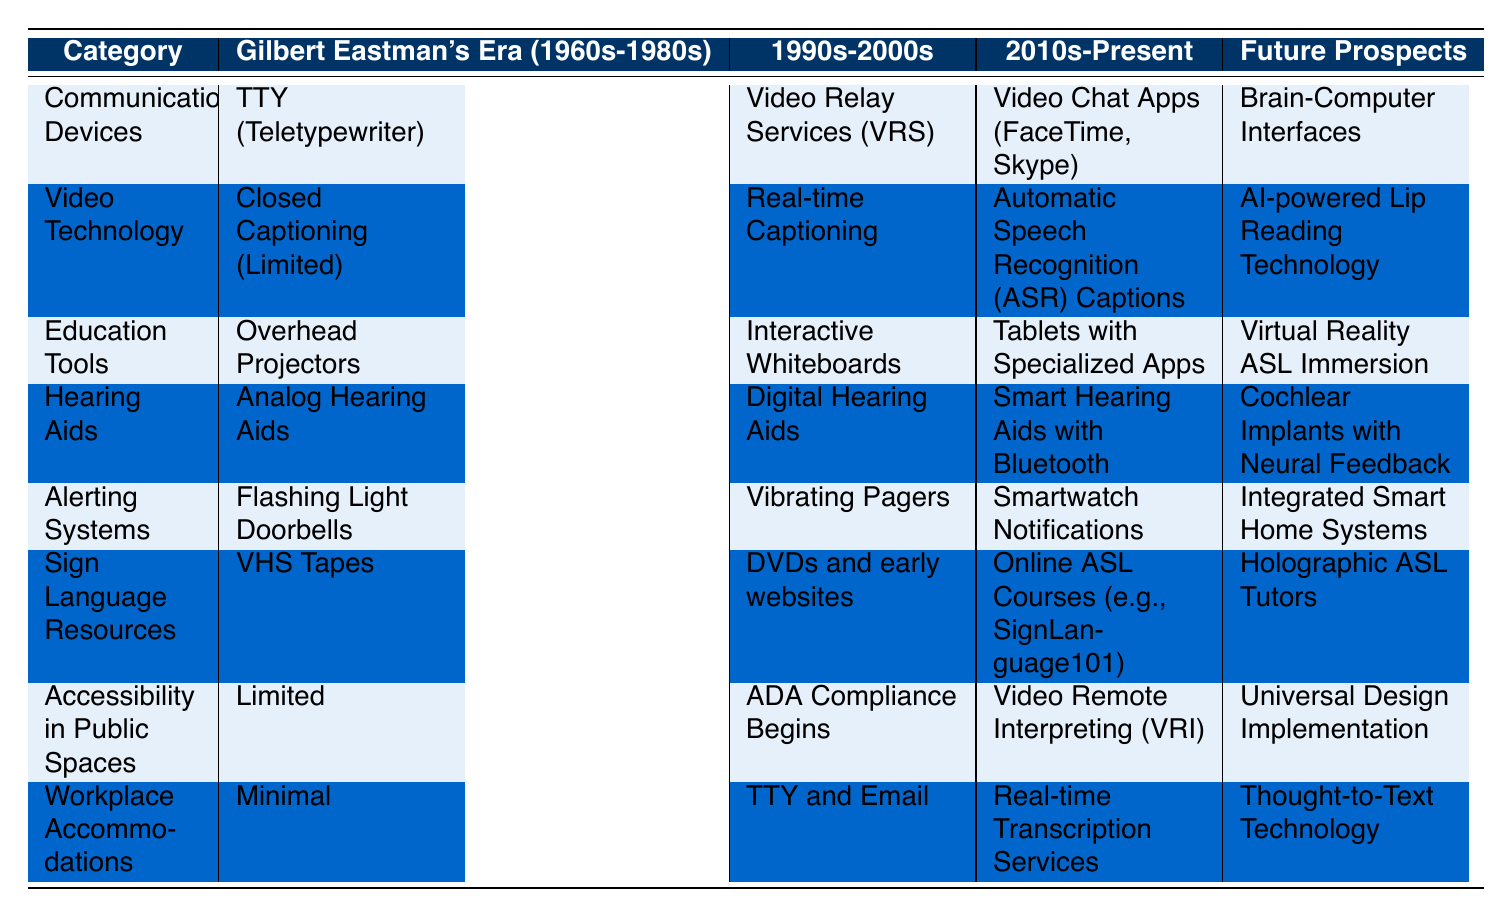What communication device was used during Gilbert Eastman's Era? According to the table, the communication device used during Gilbert Eastman's Era (1960s-1980s) was the TTY (Teletypewriter). This specific detail is found in the "Communication Devices" row under that era.
Answer: TTY (Teletypewriter) What type of hearing aids were available in the 1990s-2000s? The table indicates that during the 1990s-2000s, the type of hearing aids available were Digital Hearing Aids. This information is located in the "Hearing Aids" row for that specific era.
Answer: Digital Hearing Aids Is there a difference in accessibility in public spaces between the 2010s-Present and Future Prospects? Yes, the table shows that in the 2010s-Present, accessibility in public spaces included Video Remote Interpreting (VRI), while for Future Prospects, it is Universal Design Implementation. This indicates a progression in accessibility standards.
Answer: Yes Which era introduced Smart Hearing Aids with Bluetooth? The table shows that Smart Hearing Aids with Bluetooth were introduced in the 2010s-Present era under the "Hearing Aids" row.
Answer: 2010s-Present How many advancements in alerting systems can you identify that have occurred since Gilbert Eastman's Era? By reviewing the table, we can count three advancements: 1) Flashing Light Doorbells in Gilbert Eastman's Era, 2) Vibrating Pagers in the 1990s-2000s, and 3) Smartwatch Notifications in the 2010s-Present, along with Integrated Smart Home Systems for future prospects. This gives us a total of four unique advancements across the eras.
Answer: Four What is the difference between the communication devices of the 1990s-2000s and those of the Future Prospects? In the 1990s-2000s, the communication device was Video Relay Services (VRS), while the future prospect includes Brain-Computer Interfaces. This shows a significant advancement from reliance on video relay to direct brain-interface technology.
Answer: Video Relay Services (VRS) vs. Brain-Computer Interfaces Did the accessibility in public spaces improve over time according to the table? Yes, the table shows a trend where accessibility in public spaces was "Limited" in Gilbert Eastman's Era, progressed to "ADA Compliance Begins" in the 1990s-2000s, further evolved to "Video Remote Interpreting (VRI)" in the 2010s-Present, and aims for "Universal Design Implementation" in the Future Prospects. This indicates a clear improvement over time.
Answer: Yes What type of sign language resources became available by the 2010s-Present? The table indicates that by the 2010s-Present, sign language resources available were Online ASL Courses (e.g., SignLanguage101). This information is found in the "Sign Language Resources" row for that era.
Answer: Online ASL Courses (e.g., SignLanguage101) Which era saw the introduction of Integrated Smart Home Systems for alerting? Integrated Smart Home Systems were noted in the "Alerting Systems" row under Future Prospects. Therefore, this advancement is expected in the future beyond the present timeline.
Answer: Future Prospects 